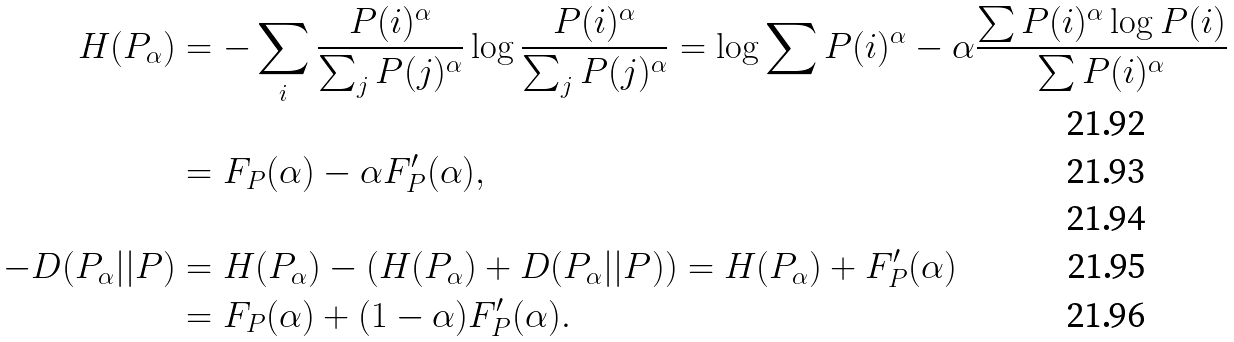<formula> <loc_0><loc_0><loc_500><loc_500>H ( P _ { \alpha } ) & = - \sum _ { i } \frac { P ( i ) ^ { \alpha } } { \sum _ { j } P ( j ) ^ { \alpha } } \log \frac { P ( i ) ^ { \alpha } } { \sum _ { j } P ( j ) ^ { \alpha } } = \log \sum P ( i ) ^ { \alpha } - \alpha \frac { \sum P ( i ) ^ { \alpha } \log P ( i ) } { \sum P ( i ) ^ { \alpha } } \\ & = F _ { P } ( \alpha ) - \alpha F _ { P } ^ { \prime } ( \alpha ) , \\ \\ - D ( P _ { \alpha } | | P ) & = H ( P _ { \alpha } ) - \left ( H ( P _ { \alpha } ) + D ( P _ { \alpha } | | P ) \right ) = H ( P _ { \alpha } ) + F _ { P } ^ { \prime } ( \alpha ) \\ & = F _ { P } ( \alpha ) + ( 1 - \alpha ) F _ { P } ^ { \prime } ( \alpha ) .</formula> 